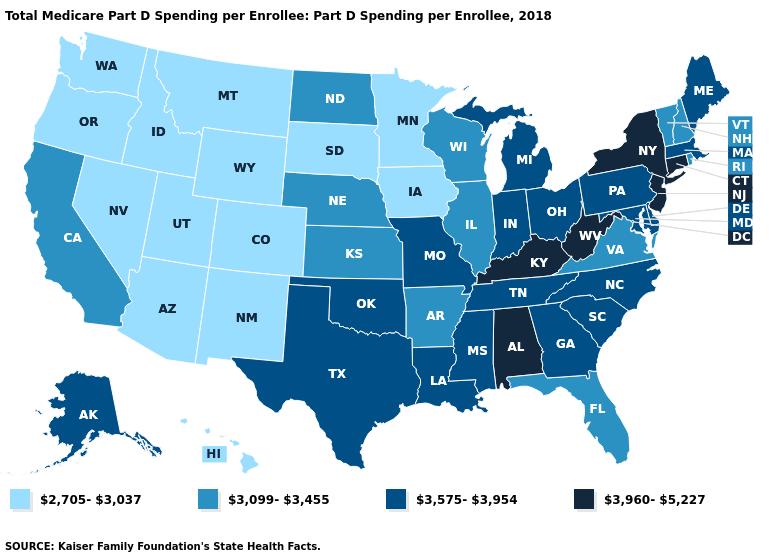What is the lowest value in states that border California?
Concise answer only. 2,705-3,037. What is the value of Montana?
Short answer required. 2,705-3,037. What is the value of Tennessee?
Answer briefly. 3,575-3,954. What is the value of Alabama?
Keep it brief. 3,960-5,227. Name the states that have a value in the range 3,575-3,954?
Write a very short answer. Alaska, Delaware, Georgia, Indiana, Louisiana, Maine, Maryland, Massachusetts, Michigan, Mississippi, Missouri, North Carolina, Ohio, Oklahoma, Pennsylvania, South Carolina, Tennessee, Texas. Does Kansas have the lowest value in the USA?
Concise answer only. No. Does Florida have the same value as Vermont?
Write a very short answer. Yes. What is the value of Ohio?
Answer briefly. 3,575-3,954. Name the states that have a value in the range 3,575-3,954?
Quick response, please. Alaska, Delaware, Georgia, Indiana, Louisiana, Maine, Maryland, Massachusetts, Michigan, Mississippi, Missouri, North Carolina, Ohio, Oklahoma, Pennsylvania, South Carolina, Tennessee, Texas. What is the value of Oklahoma?
Keep it brief. 3,575-3,954. How many symbols are there in the legend?
Give a very brief answer. 4. Which states have the lowest value in the MidWest?
Write a very short answer. Iowa, Minnesota, South Dakota. Name the states that have a value in the range 3,575-3,954?
Concise answer only. Alaska, Delaware, Georgia, Indiana, Louisiana, Maine, Maryland, Massachusetts, Michigan, Mississippi, Missouri, North Carolina, Ohio, Oklahoma, Pennsylvania, South Carolina, Tennessee, Texas. Does Kentucky have a lower value than Maryland?
Concise answer only. No. Name the states that have a value in the range 3,099-3,455?
Keep it brief. Arkansas, California, Florida, Illinois, Kansas, Nebraska, New Hampshire, North Dakota, Rhode Island, Vermont, Virginia, Wisconsin. 